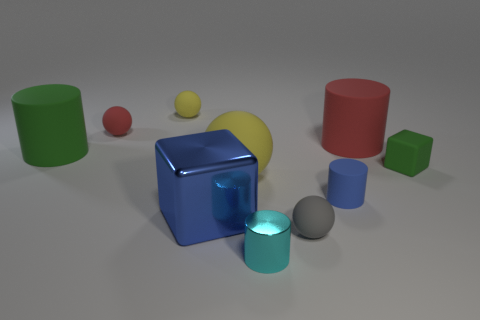There is a large cylinder left of the red cylinder on the right side of the tiny gray rubber sphere; are there any small green rubber things behind it?
Ensure brevity in your answer.  No. How many tiny things are to the left of the blue matte cylinder?
Make the answer very short. 4. What number of large metal cubes have the same color as the tiny metal cylinder?
Offer a very short reply. 0. What number of things are either spheres that are behind the tiny red thing or rubber balls to the left of the small gray matte sphere?
Give a very brief answer. 3. Is the number of small gray blocks greater than the number of small blue matte objects?
Provide a short and direct response. No. What is the color of the metal object that is in front of the large blue block?
Provide a short and direct response. Cyan. Is the shape of the small gray thing the same as the tiny cyan thing?
Provide a short and direct response. No. What is the color of the rubber cylinder that is both right of the small red rubber ball and on the left side of the red cylinder?
Your response must be concise. Blue. There is a yellow rubber sphere that is behind the red rubber sphere; is it the same size as the blue metallic thing right of the small red rubber ball?
Your answer should be compact. No. How many things are either green objects right of the big red rubber cylinder or red cylinders?
Ensure brevity in your answer.  2. 